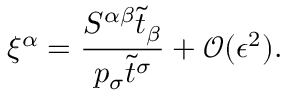<formula> <loc_0><loc_0><loc_500><loc_500>\xi ^ { \alpha } = \frac { S ^ { \alpha \beta } \tilde { t } _ { \beta } } { p _ { \sigma } \tilde { t } ^ { \sigma } } + \mathcal { O } ( \epsilon ^ { 2 } ) .</formula> 